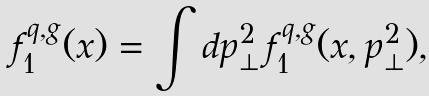<formula> <loc_0><loc_0><loc_500><loc_500>f _ { 1 } ^ { q , g } ( x ) = \int d \boldsymbol p _ { \perp } ^ { 2 } \, f _ { 1 } ^ { q , g } ( x , \boldsymbol p _ { \perp } ^ { 2 } ) ,</formula> 